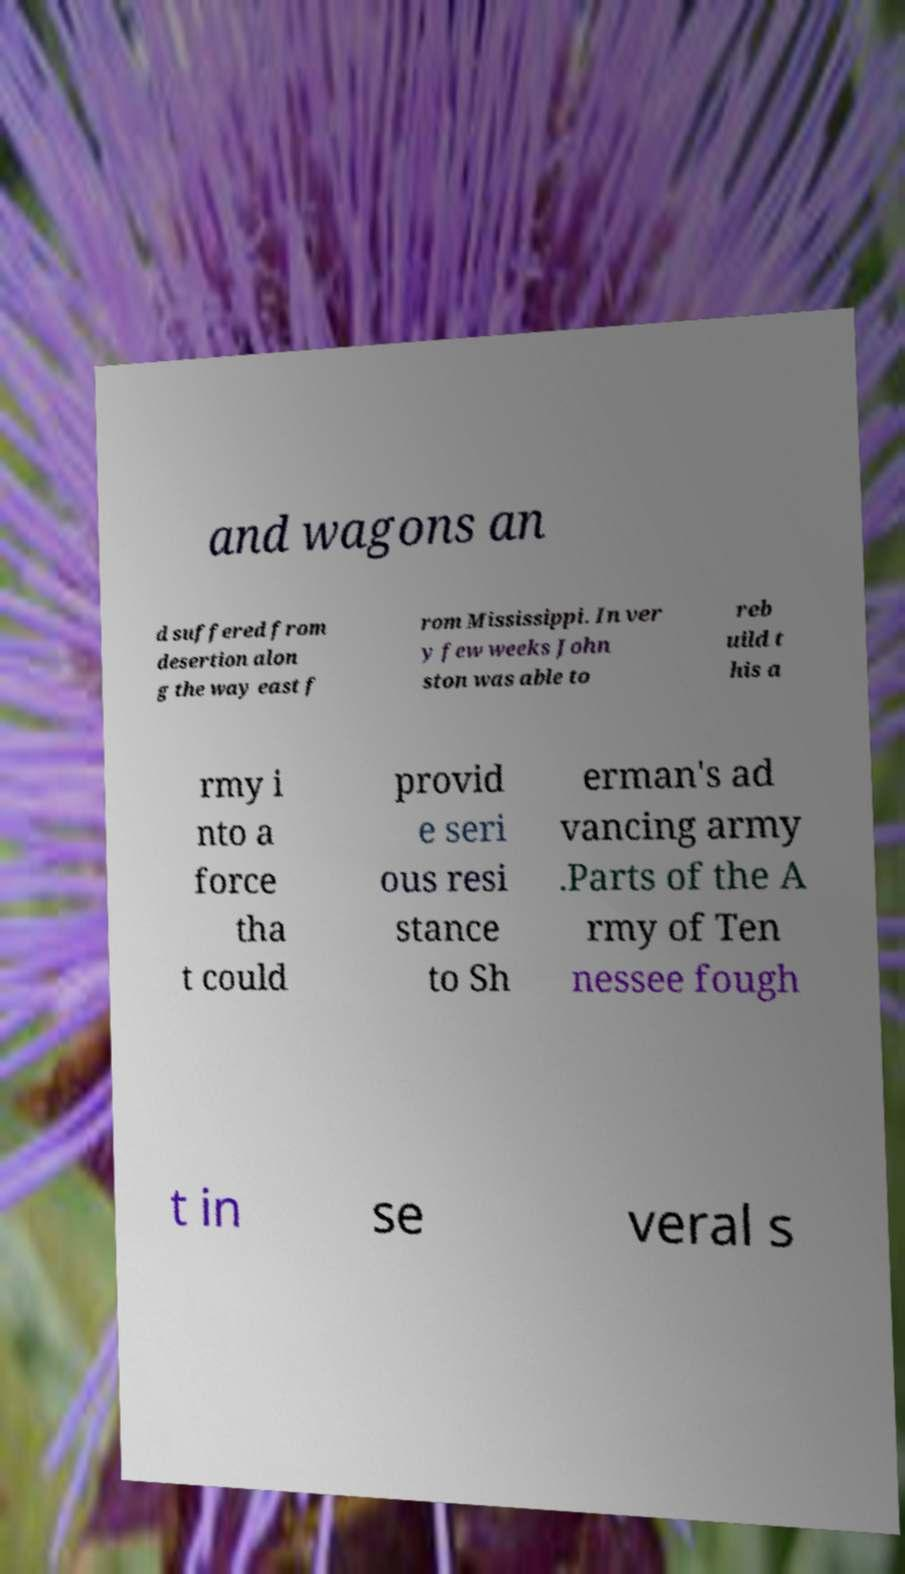Could you assist in decoding the text presented in this image and type it out clearly? and wagons an d suffered from desertion alon g the way east f rom Mississippi. In ver y few weeks John ston was able to reb uild t his a rmy i nto a force tha t could provid e seri ous resi stance to Sh erman's ad vancing army .Parts of the A rmy of Ten nessee fough t in se veral s 